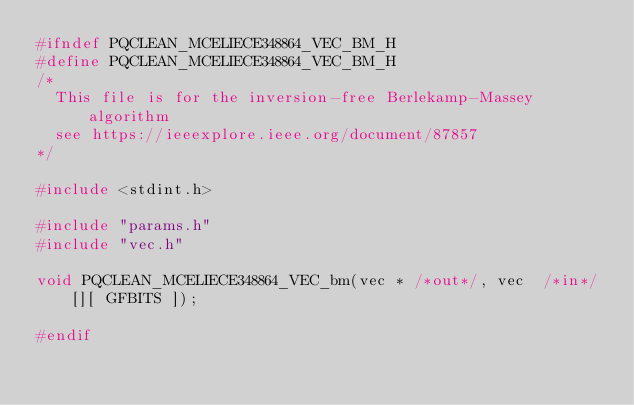Convert code to text. <code><loc_0><loc_0><loc_500><loc_500><_C_>#ifndef PQCLEAN_MCELIECE348864_VEC_BM_H
#define PQCLEAN_MCELIECE348864_VEC_BM_H
/*
  This file is for the inversion-free Berlekamp-Massey algorithm
  see https://ieeexplore.ieee.org/document/87857
*/

#include <stdint.h>

#include "params.h"
#include "vec.h"

void PQCLEAN_MCELIECE348864_VEC_bm(vec * /*out*/, vec  /*in*/[][ GFBITS ]);

#endif

</code> 